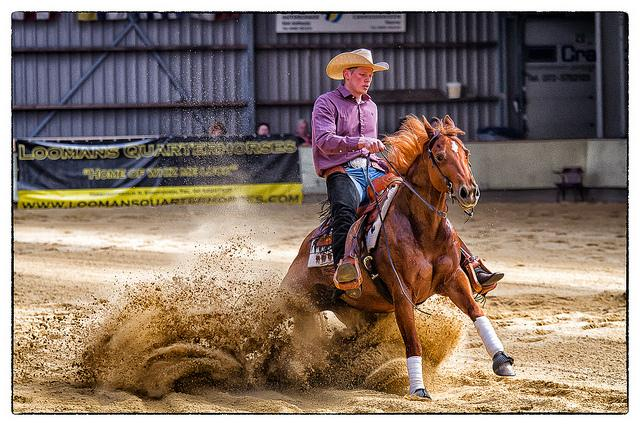What mythological creature is most similar to the one the man is riding on? unicorn 